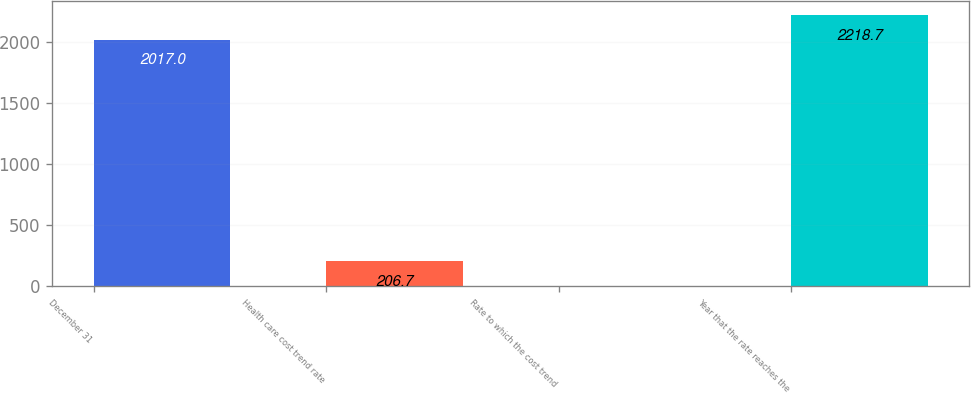Convert chart. <chart><loc_0><loc_0><loc_500><loc_500><bar_chart><fcel>December 31<fcel>Health care cost trend rate<fcel>Rate to which the cost trend<fcel>Year that the rate reaches the<nl><fcel>2017<fcel>206.7<fcel>5<fcel>2218.7<nl></chart> 